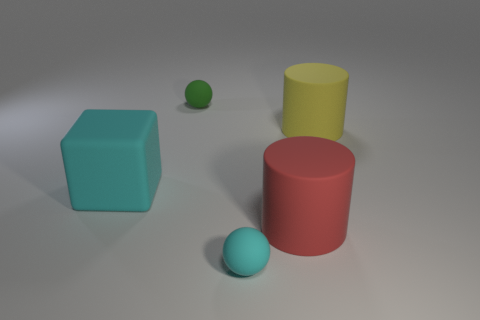There is a object that is right of the tiny green rubber ball and behind the big red rubber cylinder; what color is it? The object right of the tiny green rubber ball and behind the big red rubber cylinder is a large yellow rubber cube. Its vibrant color contrasts nicely with the other objects and adds to the visual diversity of the scene. 